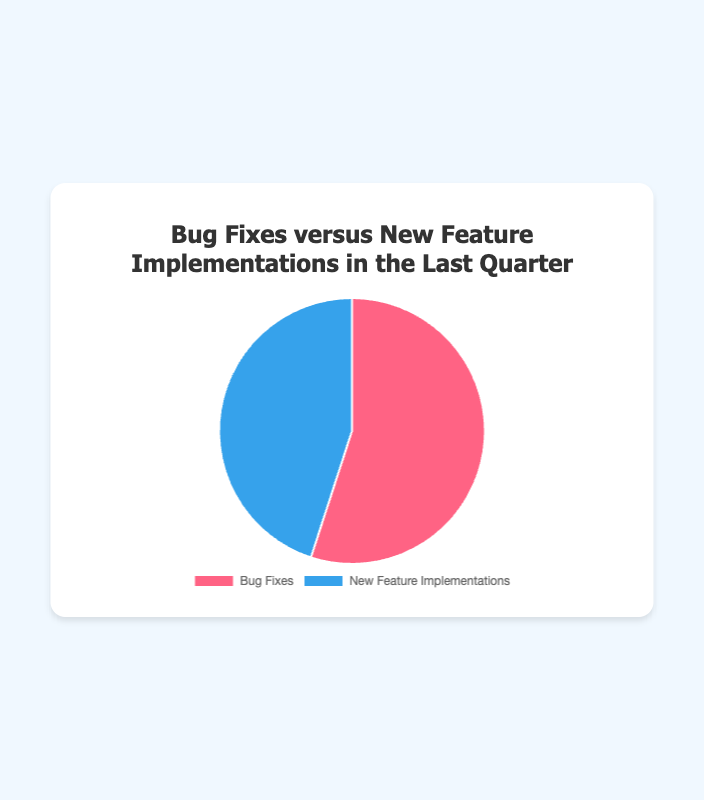What are the percentage values for Bug Fixes and New Feature Implementations? The chart shows two data points: Bug Fixes and New Feature Implementations. The Pie chart divides these into respective segments with their percentages. According to the chart, the Bug Fixes segment occupies 55% and the New Feature Implementations segment occupies 45%.
Answer: Bug Fixes: 55%, New Feature Implementations: 45% Which category had a higher percentage in the last quarter? By looking at the segments in the Pie chart, it is evident from their sizes and corresponding percentages that Bug Fixes, with 55%, has a higher percentage compared to New Feature Implementations, which stands at 45%.
Answer: Bug Fixes What is the difference in percentage between Bug Fixes and New Feature Implementations? First, identify the percentages for each category: Bug Fixes is 55% and New Feature Implementations is 45%. Then, subtract the percentage of New Feature Implementations from the percentage of Bug Fixes (55% - 45%).
Answer: 10% What is the visual color representation for each category? The Pie chart uses distinct colors for Bug Fixes and New Feature Implementations to aid visual differentiation. Bug Fixes is represented by the color red, while New Feature Implementations is represented by the color blue.
Answer: Bug Fixes: red, New Feature Implementations: blue If you were to combine both categories, what would the total percentage be? Since the Pie chart represents the entire distribution of data points, combining all categories would sum up to 100%. This means adding the percentages of Bug Fixes (55%) and New Feature Implementations (45%) gives a total of 100%.
Answer: 100% What logical interpretation can be made about the focus of work in the last quarter? The percentages (55% for Bug Fixes and 45% for New Feature Implementations) indicate a slightly greater focus on Bug Fixes. This suggests that the team spent a bit more time resolving existing issues compared to developing new features.
Answer: Focus was slightly on Bug Fixes Given the percentages shown, which category required more attention and effort from the team? By comparing the percentages, Bug Fixes (55%) required more attention and effort from the team than New Feature Implementations (45%) because it has a higher percentage.
Answer: Bug Fixes According to the Pie chart, by what percentage did Bug Fixes exceed New Feature Implementations in the last quarter? Calculate the excess by deducing the percentage of New Feature Implementations (45%) from Bug Fixes (55%). The calculation is 55% - 45%, which reveals that Bug Fixes exceeded New Feature Implementations by 10%.
Answer: 10% 